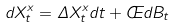<formula> <loc_0><loc_0><loc_500><loc_500>d X ^ { x } _ { t } = \Delta X ^ { x } _ { t } d t + \phi d B _ { t }</formula> 